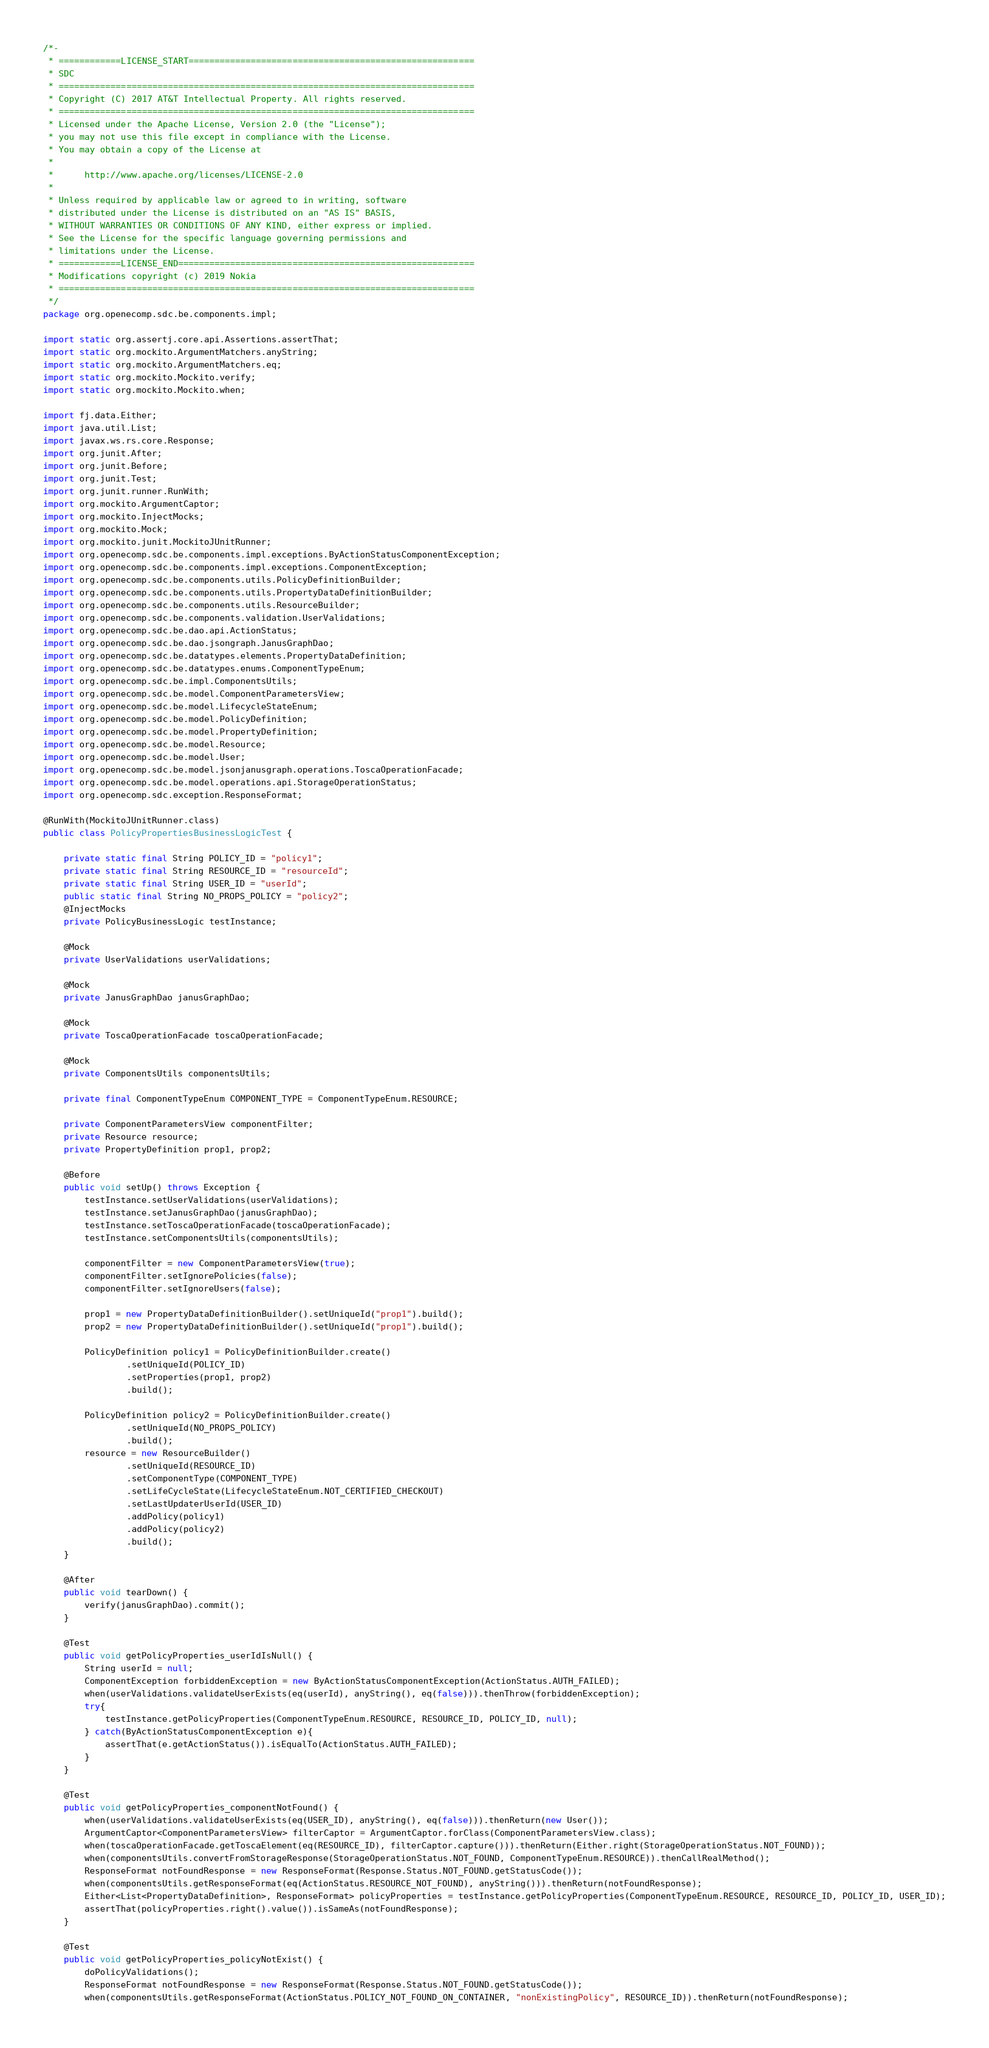Convert code to text. <code><loc_0><loc_0><loc_500><loc_500><_Java_>/*-
 * ============LICENSE_START=======================================================
 * SDC
 * ================================================================================
 * Copyright (C) 2017 AT&T Intellectual Property. All rights reserved.
 * ================================================================================
 * Licensed under the Apache License, Version 2.0 (the "License");
 * you may not use this file except in compliance with the License.
 * You may obtain a copy of the License at
 *
 *      http://www.apache.org/licenses/LICENSE-2.0
 *
 * Unless required by applicable law or agreed to in writing, software
 * distributed under the License is distributed on an "AS IS" BASIS,
 * WITHOUT WARRANTIES OR CONDITIONS OF ANY KIND, either express or implied.
 * See the License for the specific language governing permissions and
 * limitations under the License.
 * ============LICENSE_END=========================================================
 * Modifications copyright (c) 2019 Nokia
 * ================================================================================
 */
package org.openecomp.sdc.be.components.impl;

import static org.assertj.core.api.Assertions.assertThat;
import static org.mockito.ArgumentMatchers.anyString;
import static org.mockito.ArgumentMatchers.eq;
import static org.mockito.Mockito.verify;
import static org.mockito.Mockito.when;

import fj.data.Either;
import java.util.List;
import javax.ws.rs.core.Response;
import org.junit.After;
import org.junit.Before;
import org.junit.Test;
import org.junit.runner.RunWith;
import org.mockito.ArgumentCaptor;
import org.mockito.InjectMocks;
import org.mockito.Mock;
import org.mockito.junit.MockitoJUnitRunner;
import org.openecomp.sdc.be.components.impl.exceptions.ByActionStatusComponentException;
import org.openecomp.sdc.be.components.impl.exceptions.ComponentException;
import org.openecomp.sdc.be.components.utils.PolicyDefinitionBuilder;
import org.openecomp.sdc.be.components.utils.PropertyDataDefinitionBuilder;
import org.openecomp.sdc.be.components.utils.ResourceBuilder;
import org.openecomp.sdc.be.components.validation.UserValidations;
import org.openecomp.sdc.be.dao.api.ActionStatus;
import org.openecomp.sdc.be.dao.jsongraph.JanusGraphDao;
import org.openecomp.sdc.be.datatypes.elements.PropertyDataDefinition;
import org.openecomp.sdc.be.datatypes.enums.ComponentTypeEnum;
import org.openecomp.sdc.be.impl.ComponentsUtils;
import org.openecomp.sdc.be.model.ComponentParametersView;
import org.openecomp.sdc.be.model.LifecycleStateEnum;
import org.openecomp.sdc.be.model.PolicyDefinition;
import org.openecomp.sdc.be.model.PropertyDefinition;
import org.openecomp.sdc.be.model.Resource;
import org.openecomp.sdc.be.model.User;
import org.openecomp.sdc.be.model.jsonjanusgraph.operations.ToscaOperationFacade;
import org.openecomp.sdc.be.model.operations.api.StorageOperationStatus;
import org.openecomp.sdc.exception.ResponseFormat;

@RunWith(MockitoJUnitRunner.class)
public class PolicyPropertiesBusinessLogicTest {

    private static final String POLICY_ID = "policy1";
    private static final String RESOURCE_ID = "resourceId";
    private static final String USER_ID = "userId";
    public static final String NO_PROPS_POLICY = "policy2";
    @InjectMocks
    private PolicyBusinessLogic testInstance;

    @Mock
    private UserValidations userValidations;

    @Mock
    private JanusGraphDao janusGraphDao;

    @Mock
    private ToscaOperationFacade toscaOperationFacade;

    @Mock
    private ComponentsUtils componentsUtils;

    private final ComponentTypeEnum COMPONENT_TYPE = ComponentTypeEnum.RESOURCE;

    private ComponentParametersView componentFilter;
    private Resource resource;
    private PropertyDefinition prop1, prop2;

    @Before
    public void setUp() throws Exception {
        testInstance.setUserValidations(userValidations);
        testInstance.setJanusGraphDao(janusGraphDao);
        testInstance.setToscaOperationFacade(toscaOperationFacade);
        testInstance.setComponentsUtils(componentsUtils);

        componentFilter = new ComponentParametersView(true);
        componentFilter.setIgnorePolicies(false);
        componentFilter.setIgnoreUsers(false);

        prop1 = new PropertyDataDefinitionBuilder().setUniqueId("prop1").build();
        prop2 = new PropertyDataDefinitionBuilder().setUniqueId("prop1").build();

        PolicyDefinition policy1 = PolicyDefinitionBuilder.create()
                .setUniqueId(POLICY_ID)
                .setProperties(prop1, prop2)
                .build();

        PolicyDefinition policy2 = PolicyDefinitionBuilder.create()
                .setUniqueId(NO_PROPS_POLICY)
                .build();
        resource = new ResourceBuilder()
                .setUniqueId(RESOURCE_ID)
                .setComponentType(COMPONENT_TYPE)
                .setLifeCycleState(LifecycleStateEnum.NOT_CERTIFIED_CHECKOUT)
                .setLastUpdaterUserId(USER_ID)
                .addPolicy(policy1)
                .addPolicy(policy2)
                .build();
    }

    @After
    public void tearDown() {
        verify(janusGraphDao).commit();
    }

    @Test
    public void getPolicyProperties_userIdIsNull() {
        String userId = null;
        ComponentException forbiddenException = new ByActionStatusComponentException(ActionStatus.AUTH_FAILED);
        when(userValidations.validateUserExists(eq(userId), anyString(), eq(false))).thenThrow(forbiddenException);
        try{
            testInstance.getPolicyProperties(ComponentTypeEnum.RESOURCE, RESOURCE_ID, POLICY_ID, null);
        } catch(ByActionStatusComponentException e){
            assertThat(e.getActionStatus()).isEqualTo(ActionStatus.AUTH_FAILED);
        }
    }

    @Test
    public void getPolicyProperties_componentNotFound() {
        when(userValidations.validateUserExists(eq(USER_ID), anyString(), eq(false))).thenReturn(new User());
        ArgumentCaptor<ComponentParametersView> filterCaptor = ArgumentCaptor.forClass(ComponentParametersView.class);
        when(toscaOperationFacade.getToscaElement(eq(RESOURCE_ID), filterCaptor.capture())).thenReturn(Either.right(StorageOperationStatus.NOT_FOUND));
        when(componentsUtils.convertFromStorageResponse(StorageOperationStatus.NOT_FOUND, ComponentTypeEnum.RESOURCE)).thenCallRealMethod();
        ResponseFormat notFoundResponse = new ResponseFormat(Response.Status.NOT_FOUND.getStatusCode());
        when(componentsUtils.getResponseFormat(eq(ActionStatus.RESOURCE_NOT_FOUND), anyString())).thenReturn(notFoundResponse);
        Either<List<PropertyDataDefinition>, ResponseFormat> policyProperties = testInstance.getPolicyProperties(ComponentTypeEnum.RESOURCE, RESOURCE_ID, POLICY_ID, USER_ID);
        assertThat(policyProperties.right().value()).isSameAs(notFoundResponse);
    }

    @Test
    public void getPolicyProperties_policyNotExist() {
        doPolicyValidations();
        ResponseFormat notFoundResponse = new ResponseFormat(Response.Status.NOT_FOUND.getStatusCode());
        when(componentsUtils.getResponseFormat(ActionStatus.POLICY_NOT_FOUND_ON_CONTAINER, "nonExistingPolicy", RESOURCE_ID)).thenReturn(notFoundResponse);</code> 